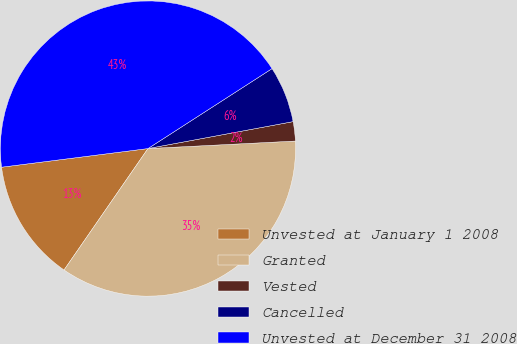Convert chart to OTSL. <chart><loc_0><loc_0><loc_500><loc_500><pie_chart><fcel>Unvested at January 1 2008<fcel>Granted<fcel>Vested<fcel>Cancelled<fcel>Unvested at December 31 2008<nl><fcel>13.36%<fcel>35.44%<fcel>2.11%<fcel>6.19%<fcel>42.91%<nl></chart> 